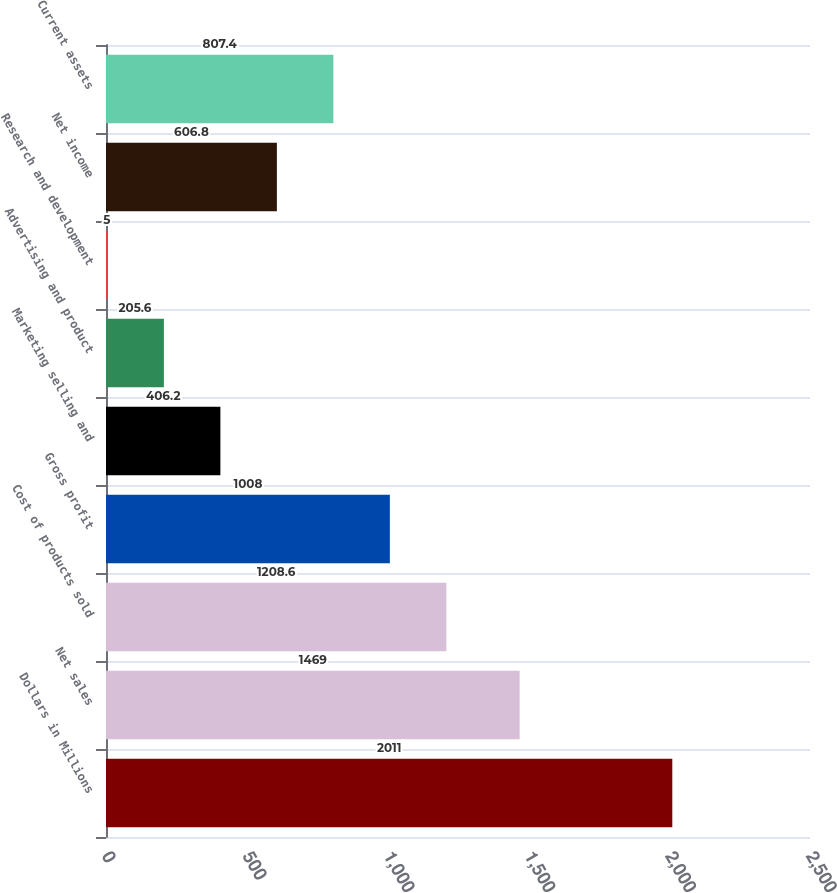Convert chart to OTSL. <chart><loc_0><loc_0><loc_500><loc_500><bar_chart><fcel>Dollars in Millions<fcel>Net sales<fcel>Cost of products sold<fcel>Gross profit<fcel>Marketing selling and<fcel>Advertising and product<fcel>Research and development<fcel>Net income<fcel>Current assets<nl><fcel>2011<fcel>1469<fcel>1208.6<fcel>1008<fcel>406.2<fcel>205.6<fcel>5<fcel>606.8<fcel>807.4<nl></chart> 